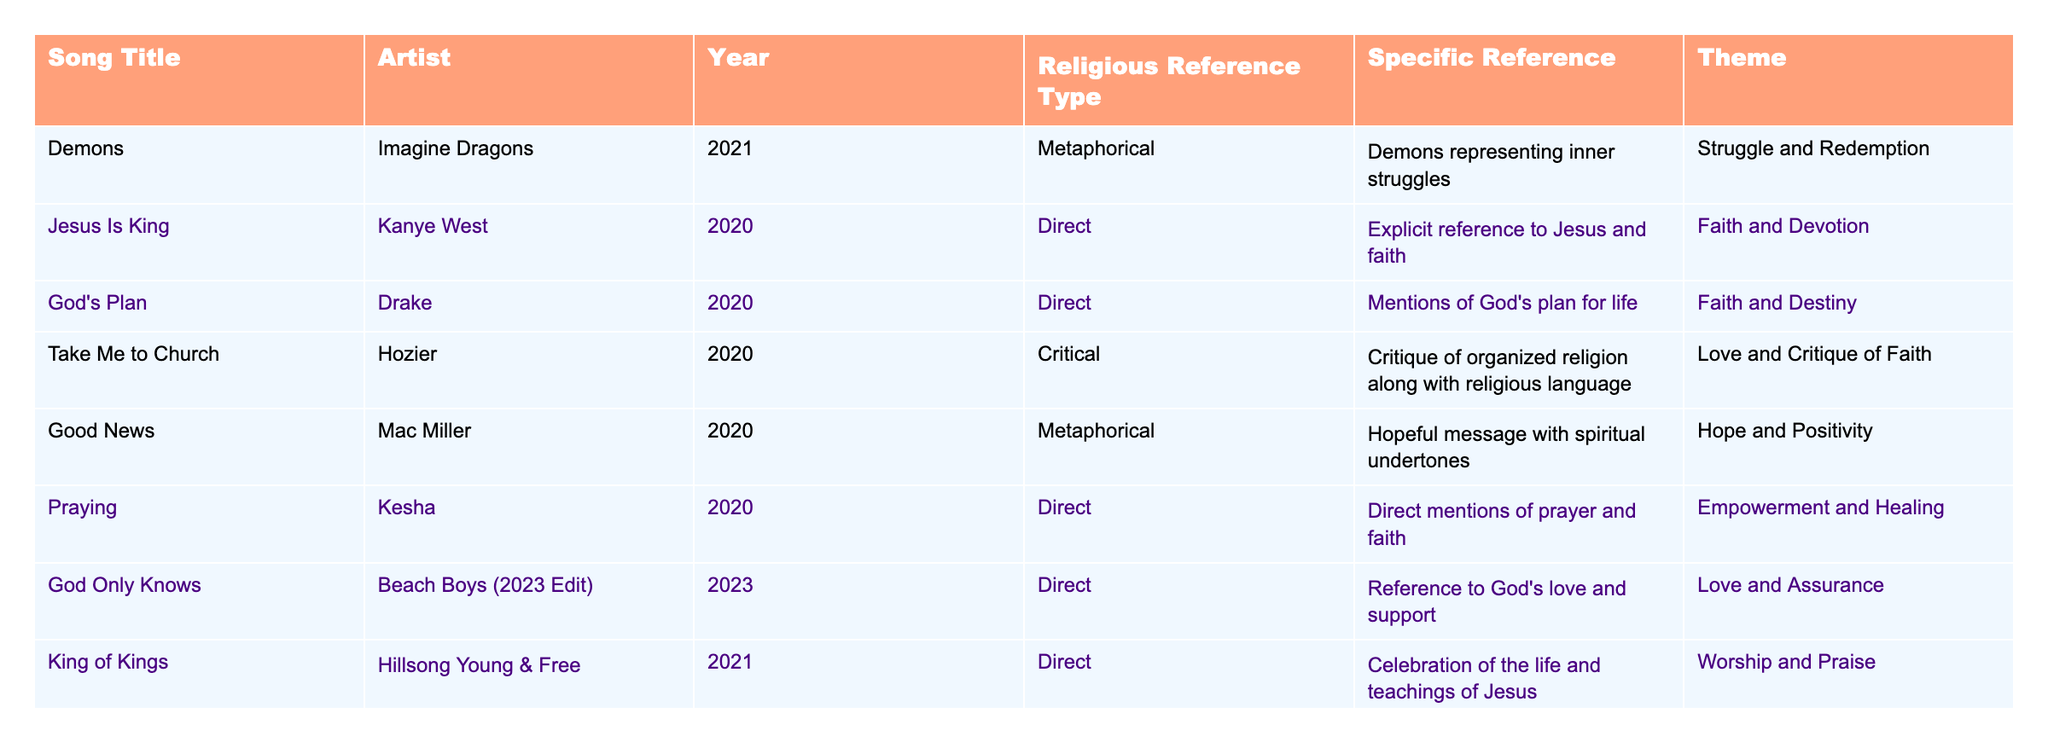What is the most recent song in the table? The most recent year in the table is 2023, which corresponds to the song "God Only Knows".
Answer: "God Only Knows" How many songs contain direct religious references? In the table, the "Religious Reference Type" column indicates which songs have direct references. There are 7 songs labeled as "Direct".
Answer: 7 What themes are represented in the song "Take Me to Church"? The table specifies that the theme for "Take Me to Church" is "Love and Critique of Faith".
Answer: Love and Critique of Faith Which song references demons metaphorically? The song "Demons" by Imagine Dragons is listed with "Metaphorical" in the "Religious Reference Type" column.
Answer: "Demons" Is there any song that discusses empowerment and healing in a religious context? Yes, "Praying" by Kesha explicitly mentions empowerment and healing as the theme.
Answer: Yes What is the average year of release for the songs listed in the table? The years are 2020, 2020, 2020, 2021, 2020, 2020, 2023, 2021, 2023, 2020, and 2023, totaling 11 years. When we sum these years (20 + 20 + 20 + 21 + 20 + 20 + 23 + 21 + 23 + 20 + 23) = 229 and divide by 11, we get approximately 20.82. Rounding gives a 2021 average.
Answer: 2021 Which artist is associated with the song that mentions God's love and support? The artist associated with "God Only Knows," which mentions God's love and support, is the Beach Boys.
Answer: Beach Boys How many songs focus on themes of love? The themes of the songs are "Love and Critique of Faith," "Love and Assurance," and "Love and Faith," which account for three songs focused on love themes.
Answer: 3 What is the relationship between the song "Faith" and its theme? The theme for the song "Faith" is represented as "Faith and Belief," showing a direct relationship between the title and the theme of faith.
Answer: Faith and Belief Which song critiques organized religion? "Take Me to Church" by Hozier is noted in the table as a critique of organized religion.
Answer: "Take Me to Church" Are there any songs released in the same year? Yes, there are multiple songs released in 2020, thus belonging to the same year.
Answer: Yes 